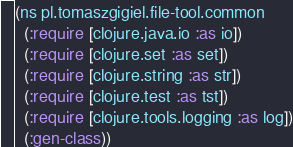Convert code to text. <code><loc_0><loc_0><loc_500><loc_500><_Clojure_>(ns pl.tomaszgigiel.file-tool.common
  (:require [clojure.java.io :as io])
  (:require [clojure.set :as set])
  (:require [clojure.string :as str])
  (:require [clojure.test :as tst])
  (:require [clojure.tools.logging :as log])
  (:gen-class))
</code> 